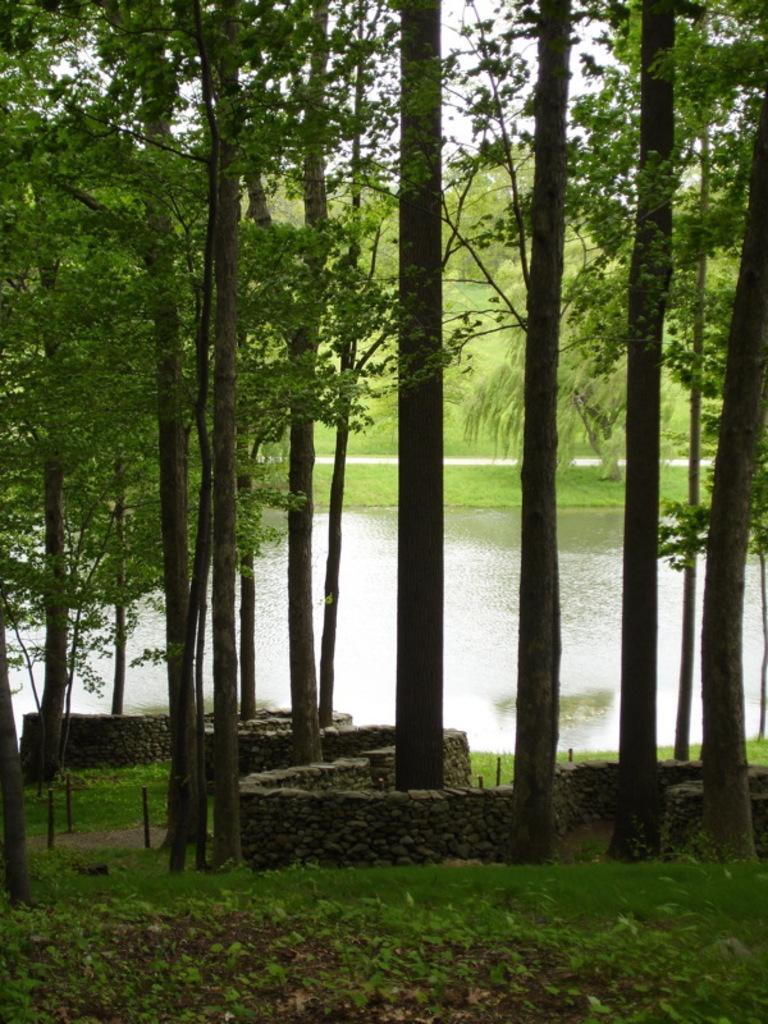Please provide a concise description of this image. These are the trees, this is water in the middle of an image. 